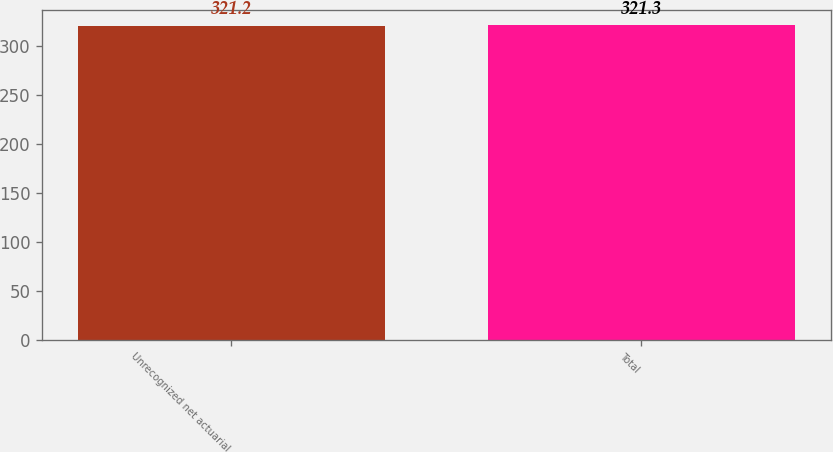<chart> <loc_0><loc_0><loc_500><loc_500><bar_chart><fcel>Unrecognized net actuarial<fcel>Total<nl><fcel>321.2<fcel>321.3<nl></chart> 